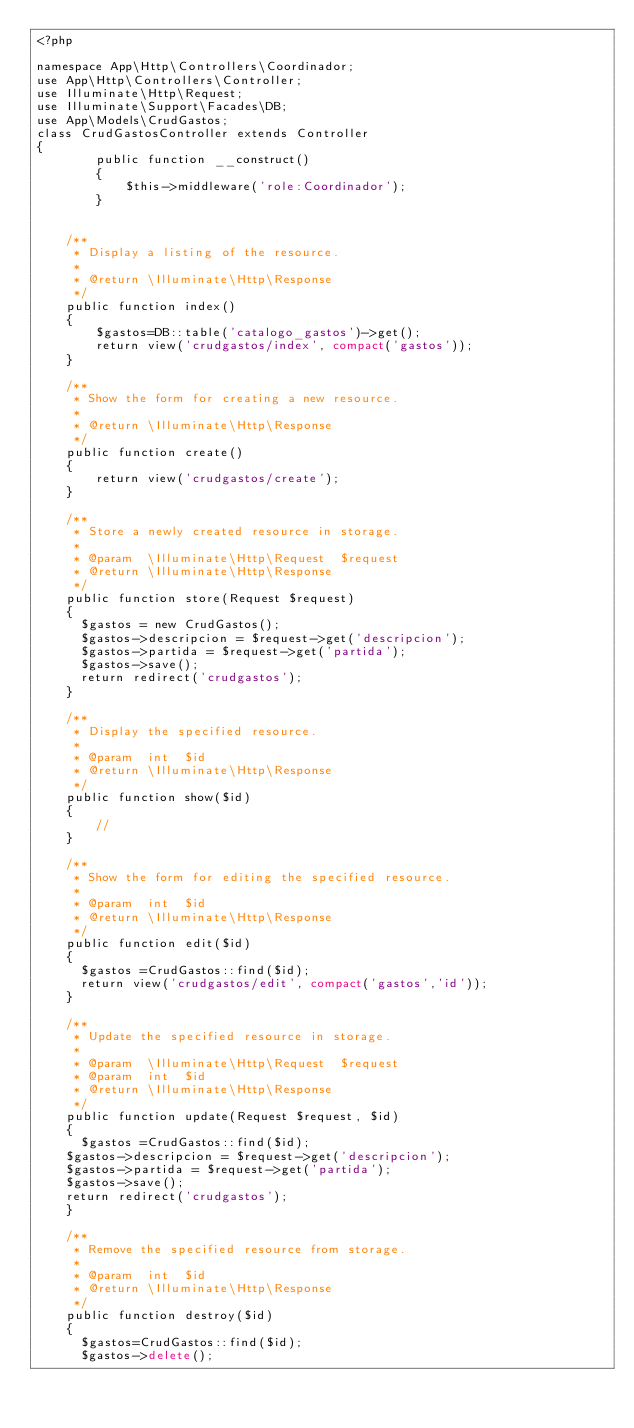Convert code to text. <code><loc_0><loc_0><loc_500><loc_500><_PHP_><?php

namespace App\Http\Controllers\Coordinador;
use App\Http\Controllers\Controller;
use Illuminate\Http\Request;
use Illuminate\Support\Facades\DB;
use App\Models\CrudGastos;
class CrudGastosController extends Controller
{
        public function __construct()
        {
            $this->middleware('role:Coordinador');
        }


    /**
     * Display a listing of the resource.
     *
     * @return \Illuminate\Http\Response
     */
    public function index()
    {
        $gastos=DB::table('catalogo_gastos')->get();
        return view('crudgastos/index', compact('gastos'));
    }

    /**
     * Show the form for creating a new resource.
     *
     * @return \Illuminate\Http\Response
     */
    public function create()
    {
        return view('crudgastos/create');
    }

    /**
     * Store a newly created resource in storage.
     *
     * @param  \Illuminate\Http\Request  $request
     * @return \Illuminate\Http\Response
     */
    public function store(Request $request)
    {
      $gastos = new CrudGastos();
      $gastos->descripcion = $request->get('descripcion');
      $gastos->partida = $request->get('partida');
      $gastos->save();
      return redirect('crudgastos');
    }

    /**
     * Display the specified resource.
     *
     * @param  int  $id
     * @return \Illuminate\Http\Response
     */
    public function show($id)
    {
        //
    }

    /**
     * Show the form for editing the specified resource.
     *
     * @param  int  $id
     * @return \Illuminate\Http\Response
     */
    public function edit($id)
    {
      $gastos =CrudGastos::find($id);
      return view('crudgastos/edit', compact('gastos','id'));
    }

    /**
     * Update the specified resource in storage.
     *
     * @param  \Illuminate\Http\Request  $request
     * @param  int  $id
     * @return \Illuminate\Http\Response
     */
    public function update(Request $request, $id)
    {
      $gastos =CrudGastos::find($id);
    $gastos->descripcion = $request->get('descripcion');
    $gastos->partida = $request->get('partida');
    $gastos->save();
    return redirect('crudgastos');
    }

    /**
     * Remove the specified resource from storage.
     *
     * @param  int  $id
     * @return \Illuminate\Http\Response
     */
    public function destroy($id)
    {
      $gastos=CrudGastos::find($id);
      $gastos->delete();</code> 